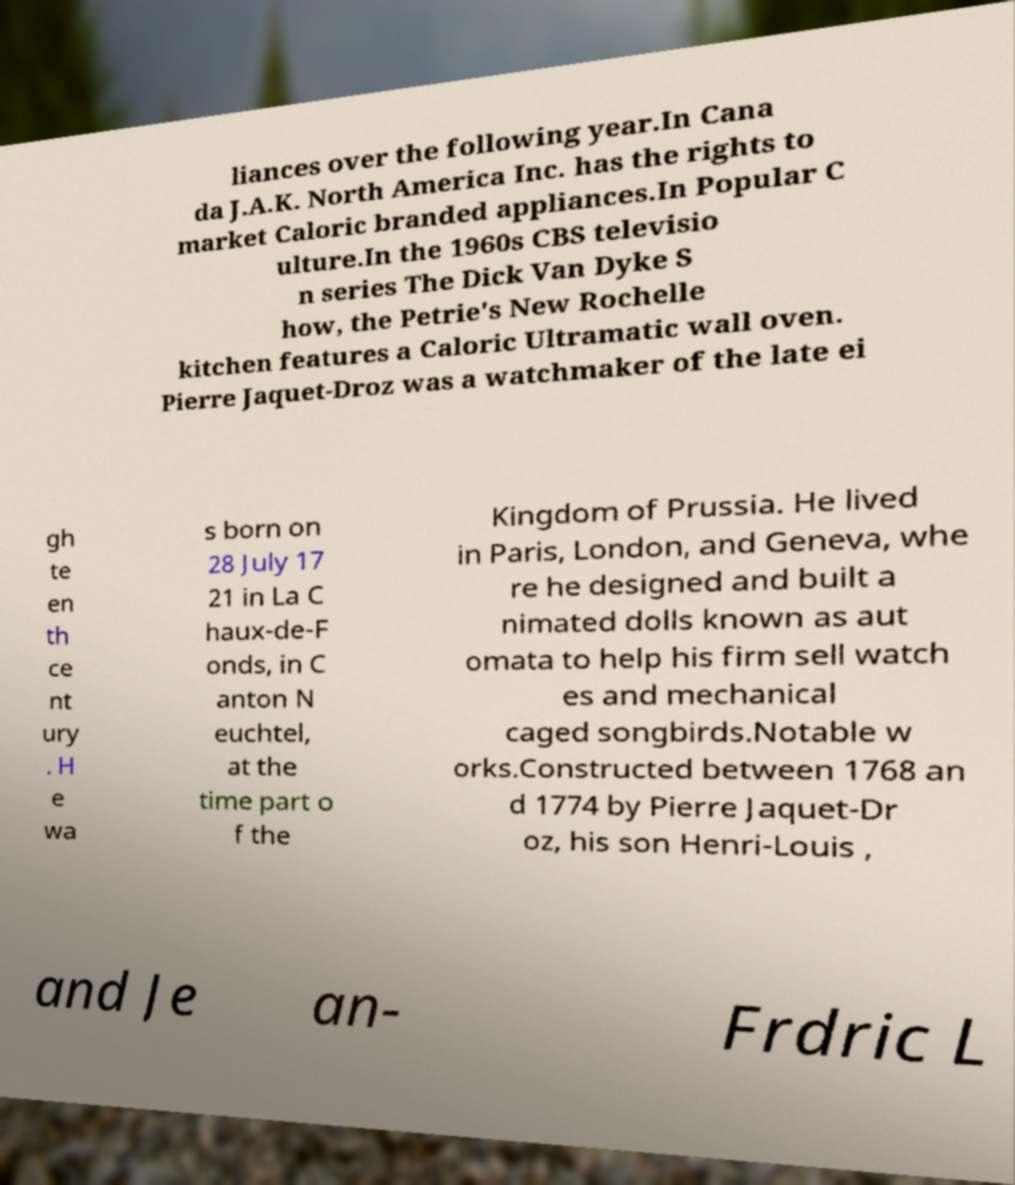Could you extract and type out the text from this image? liances over the following year.In Cana da J.A.K. North America Inc. has the rights to market Caloric branded appliances.In Popular C ulture.In the 1960s CBS televisio n series The Dick Van Dyke S how, the Petrie's New Rochelle kitchen features a Caloric Ultramatic wall oven. Pierre Jaquet-Droz was a watchmaker of the late ei gh te en th ce nt ury . H e wa s born on 28 July 17 21 in La C haux-de-F onds, in C anton N euchtel, at the time part o f the Kingdom of Prussia. He lived in Paris, London, and Geneva, whe re he designed and built a nimated dolls known as aut omata to help his firm sell watch es and mechanical caged songbirds.Notable w orks.Constructed between 1768 an d 1774 by Pierre Jaquet-Dr oz, his son Henri-Louis , and Je an- Frdric L 